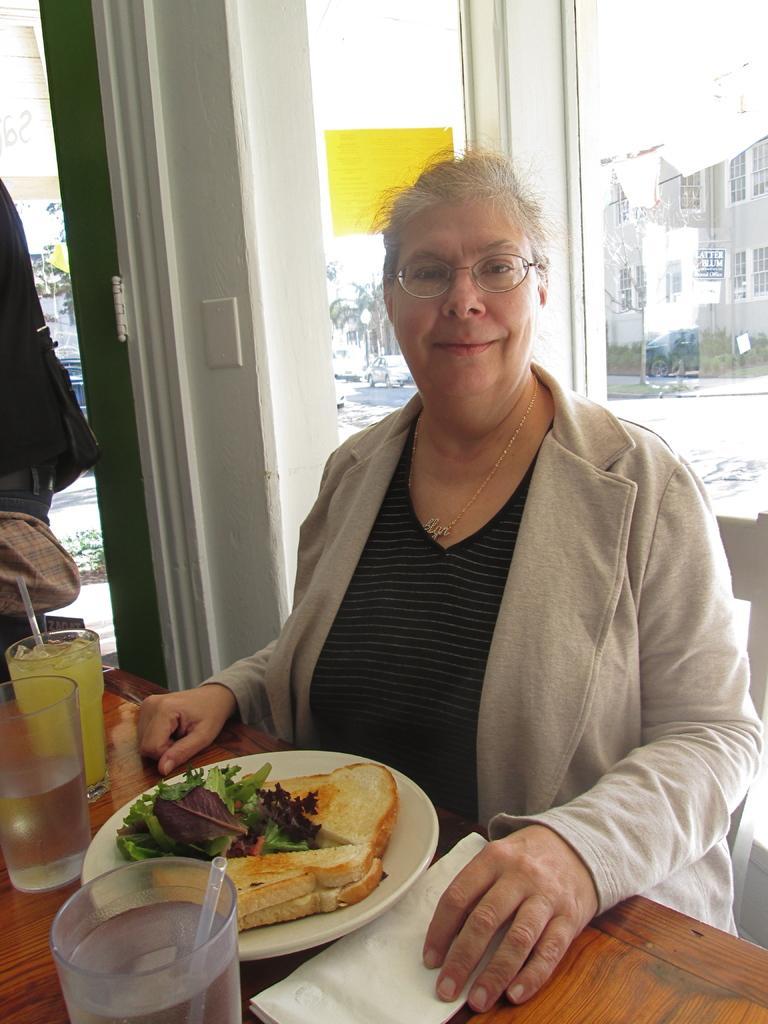Please provide a concise description of this image. In this image, there is a person wearing clothes and sitting on the chair in front of the table. This table contains glasses and and plate. There is a window at the top of the image. 